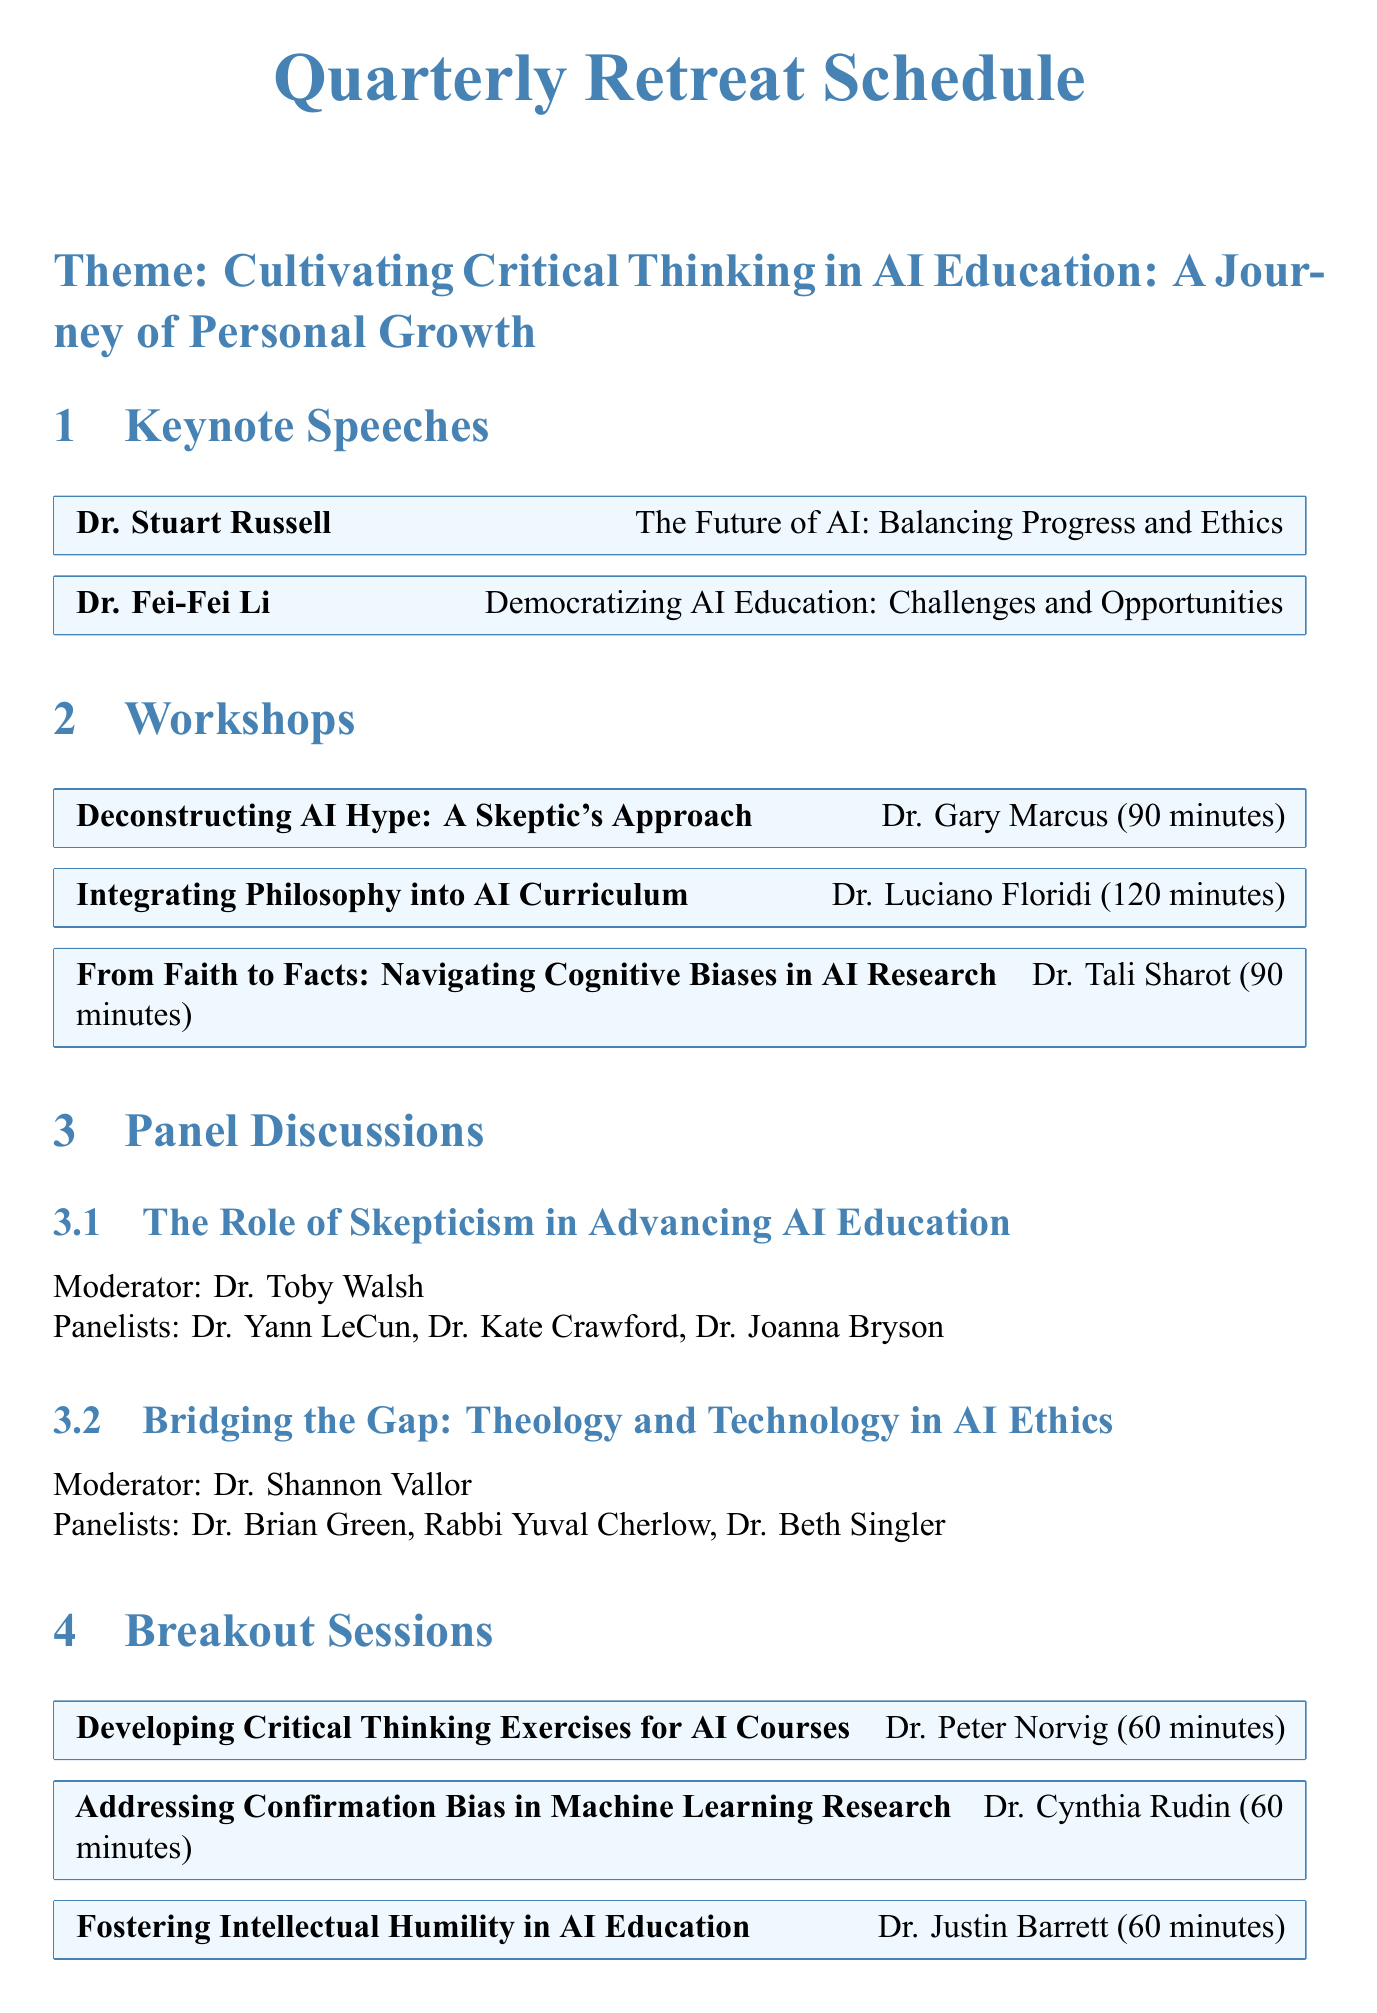What is the theme of the retreat? The theme is the main focus and title of the retreat highlighted in the document.
Answer: Cultivating Critical Thinking in AI Education: A Journey of Personal Growth Who is the first keynote speaker? The first keynote speaker mentioned in the document is the individual who speaks first at the retreat.
Answer: Dr. Stuart Russell How long is the workshop titled "Integrating Philosophy into AI Curriculum"? The duration of this workshop is specified in the document.
Answer: 120 minutes Who moderates the panel discussion on skepticism? The document lists the moderator for this specific panel discussion.
Answer: Dr. Toby Walsh What is the duration of the reflection activity titled "Journaling: Reconciling Faith and Science in AI Education"? This duration is clearly stated in the document under the reflection activities.
Answer: 45 minutes How many panelists are on the panel discussing theology and technology in AI ethics? The total number of panelists for this discussion can be counted based on the information provided.
Answer: 3 What is the venue for the networking event "AI Educators' Mixer"? The document specifies the location for this specific networking event.
Answer: Turing Terrace What is the title of the closing ceremony? The title is the name of the event that concludes the retreat, as listed in the document.
Answer: Embracing Doubt, Fostering Growth: The Future of AI Education What exercise involves arguing both sides? The document mentions this specific team-building exercise that focuses on debate.
Answer: AI Debate Club: Arguing Both Sides 